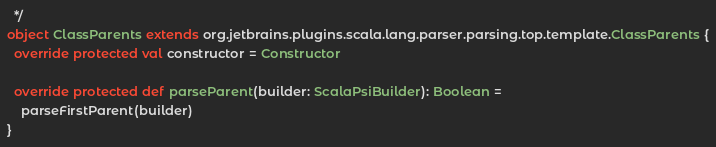Convert code to text. <code><loc_0><loc_0><loc_500><loc_500><_Scala_>  */
object ClassParents extends org.jetbrains.plugins.scala.lang.parser.parsing.top.template.ClassParents {
  override protected val constructor = Constructor

  override protected def parseParent(builder: ScalaPsiBuilder): Boolean =
    parseFirstParent(builder)
}
</code> 